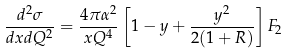Convert formula to latex. <formula><loc_0><loc_0><loc_500><loc_500>\frac { d ^ { 2 } \sigma } { d x d Q ^ { 2 } } = \frac { 4 \pi \alpha ^ { 2 } } { x Q ^ { 4 } } \left [ 1 - y + \frac { y ^ { 2 } } { 2 ( 1 + R ) } \right ] F _ { 2 }</formula> 